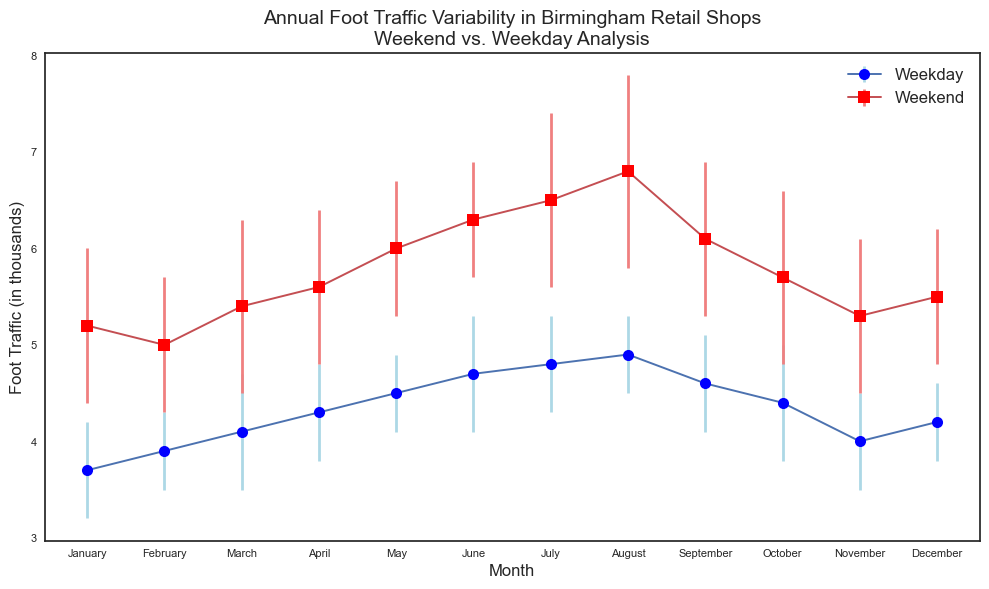What is the average foot traffic on weekdays in June? Look at the weekday line for the month of June, observe the point's value, which is marked along the vertical axis as 4.7 thousand.
Answer: 4.7 thousand Which month has the highest average weekend foot traffic? Look at the weekend line and identify the highest point, which occurs in August.
Answer: August What is the difference between the average weekend foot traffic and average weekday foot traffic in April? Find the values for April: Weekday (4.3 thousand) and Weekend (5.6 thousand). Subtract the weekday value from the weekend value: 5.6 - 4.3 = 1.3 thousand.
Answer: 1.3 thousand Which month shows the greatest variability in weekend foot traffic? Look at the error bars on the weekend line and identify the longest one, which occurs in August.
Answer: August What is the average of the standard deviations for weekday foot traffic across all months? Sum the standard deviations for all weekdays (0.5 + 0.4 + 0.6 + 0.5 + 0.4 + 0.6 + 0.5 + 0.4 + 0.5 + 0.6 + 0.5 + 0.4 = 5.9). Then divide by the number of months (12): 5.9 / 12 ≈ 0.492.
Answer: 0.492 In which months does the average weekday foot traffic exceed the average weekend foot traffic? Compare weekday and weekend values for each month. None of the months show an average weekday foot traffic greater than weekend foot traffic.
Answer: None Comparing the standard deviations, which month shows more consistent foot traffic on weekends than weekdays? Look at each month’s error bars and compare their lengths. Most months have a larger variance on weekends. Specifically, May shows more consistent weekend traffic with a smaller standard deviation of 0.7 compared to weekdays' 0.4.
Answer: May What is the combined average foot traffic for both weekdays and weekends in December? Add the average weekday and weekend foot traffic for December: 4.2 (weekdays) + 5.5 (weekends) = 9.7 thousand.
Answer: 9.7 thousand How does the average foot traffic in January on weekends compare to that in December? Look at the values for weekends in January (5.2 thousand) and December (5.5 thousand). January has 0.3 thousand less foot traffic than December.
Answer: January is 0.3 thousand less than December 